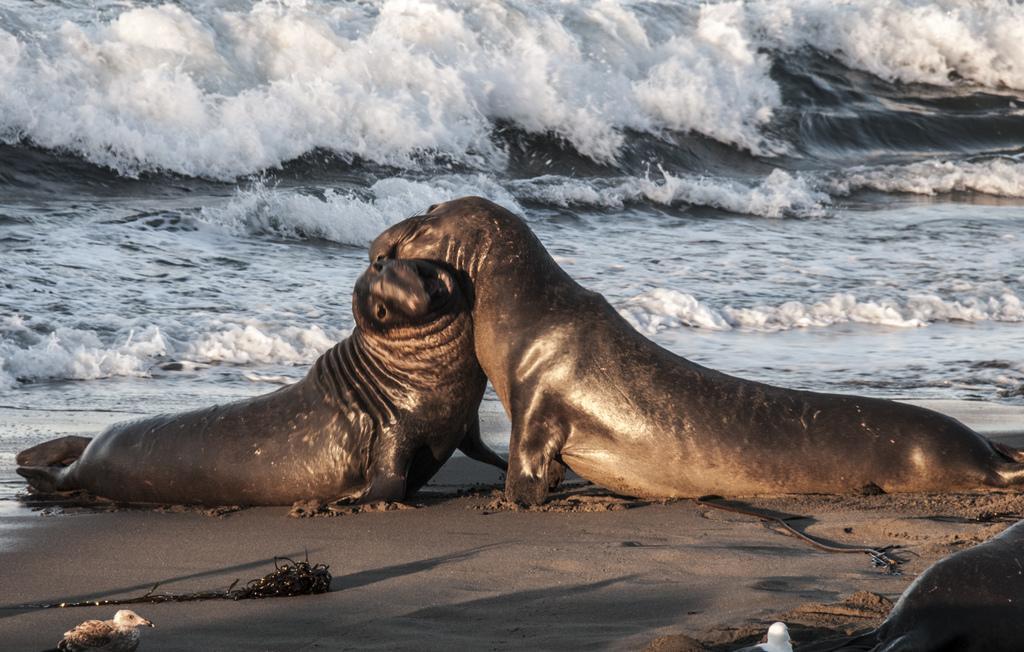Could you give a brief overview of what you see in this image? In this image I can see three seals on the beach. In the background I can see water. This image is taken may be near the ocean during a day. 